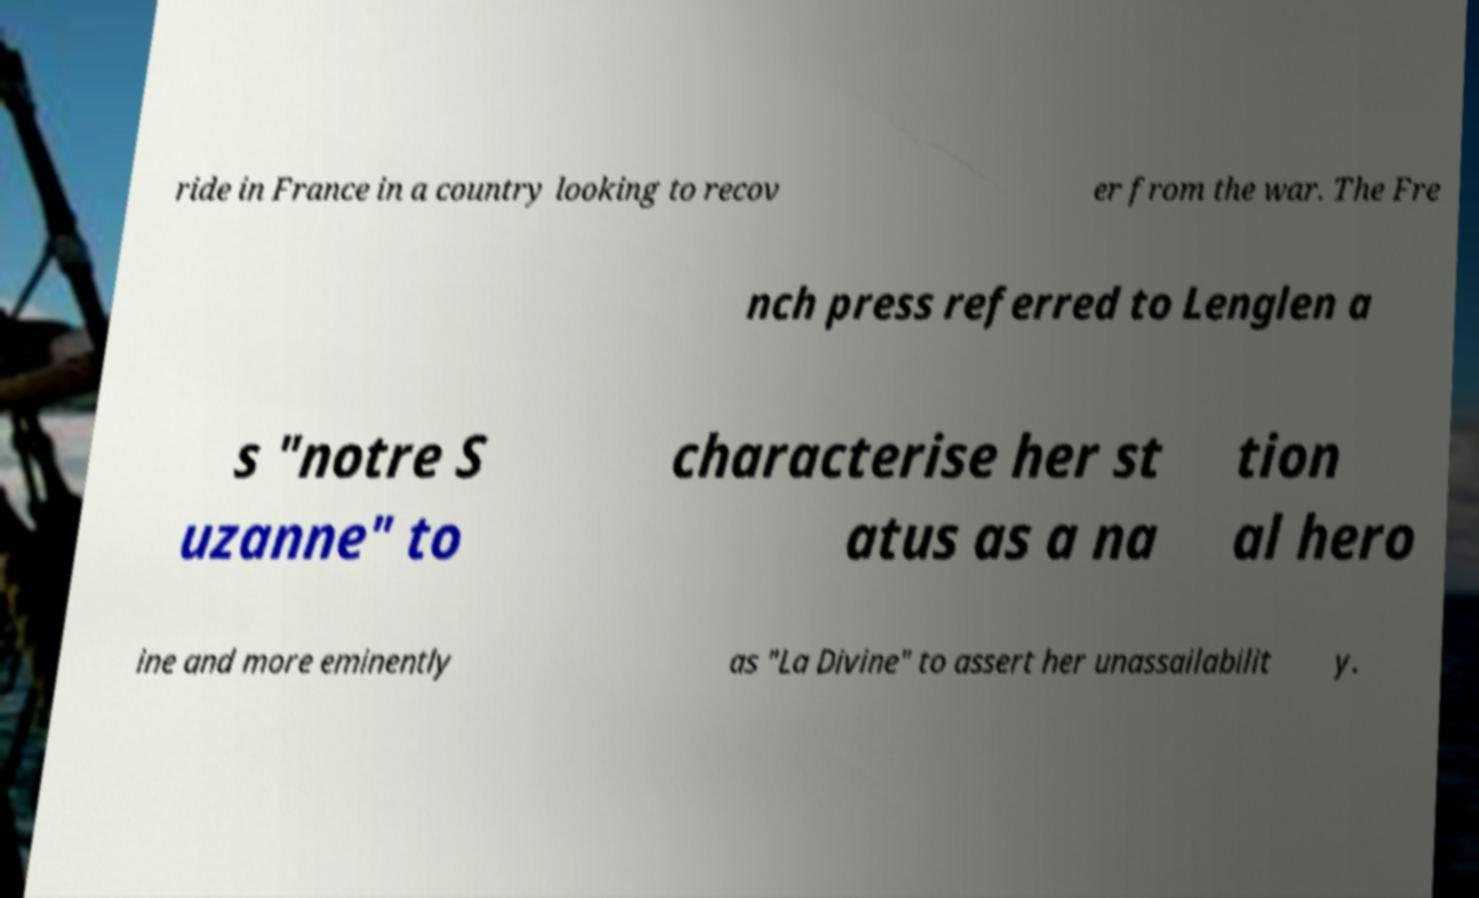Please identify and transcribe the text found in this image. ride in France in a country looking to recov er from the war. The Fre nch press referred to Lenglen a s "notre S uzanne" to characterise her st atus as a na tion al hero ine and more eminently as "La Divine" to assert her unassailabilit y. 